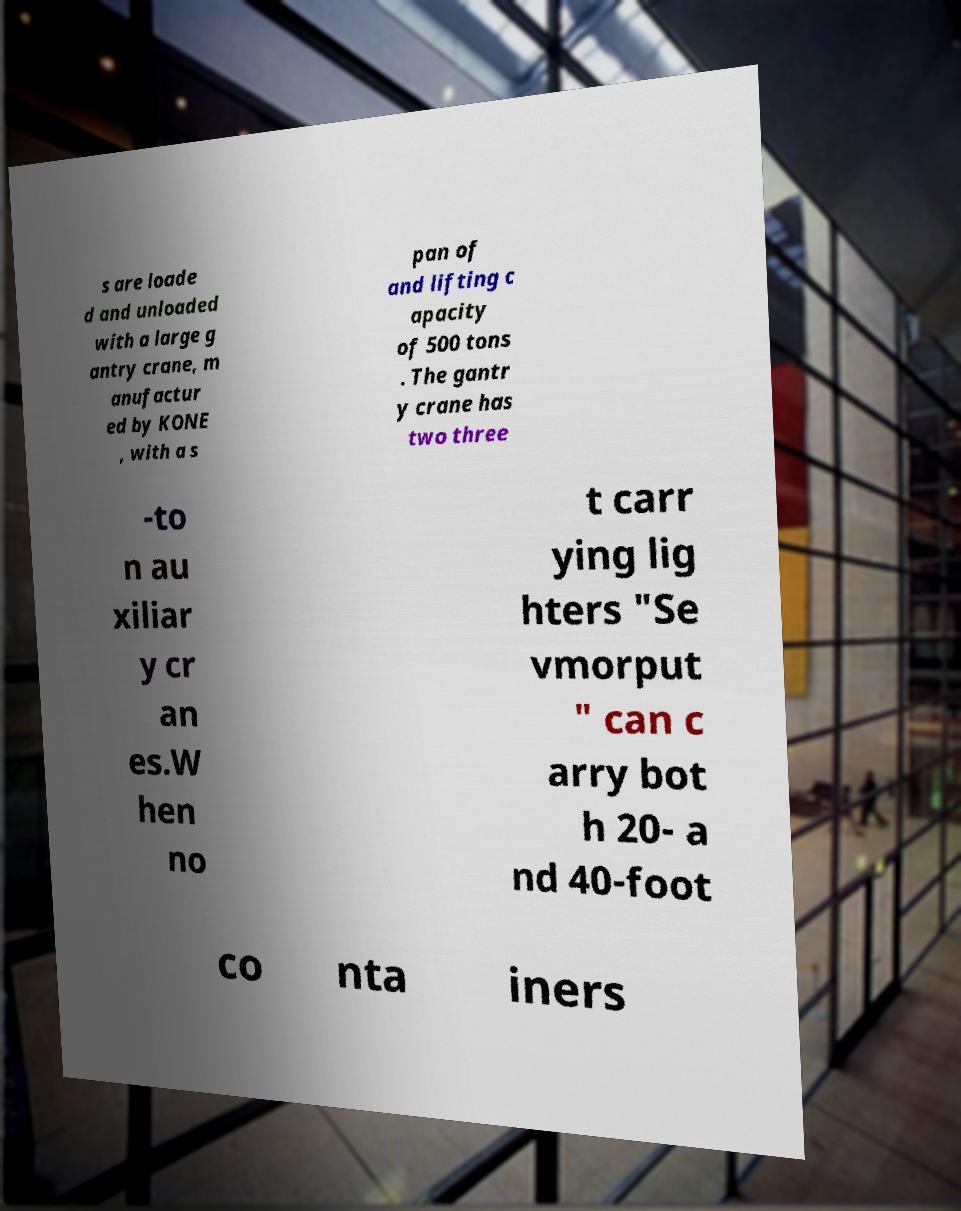Could you extract and type out the text from this image? s are loade d and unloaded with a large g antry crane, m anufactur ed by KONE , with a s pan of and lifting c apacity of 500 tons . The gantr y crane has two three -to n au xiliar y cr an es.W hen no t carr ying lig hters "Se vmorput " can c arry bot h 20- a nd 40-foot co nta iners 